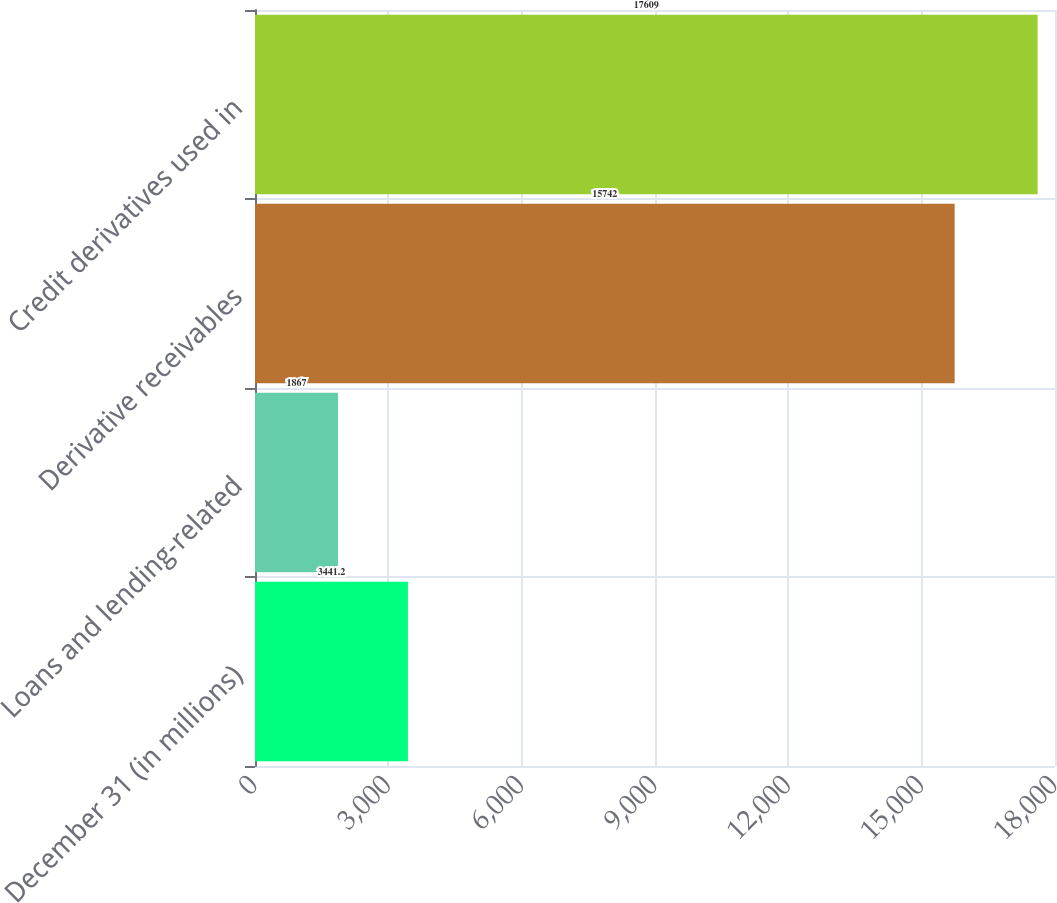<chart> <loc_0><loc_0><loc_500><loc_500><bar_chart><fcel>December 31 (in millions)<fcel>Loans and lending-related<fcel>Derivative receivables<fcel>Credit derivatives used in<nl><fcel>3441.2<fcel>1867<fcel>15742<fcel>17609<nl></chart> 